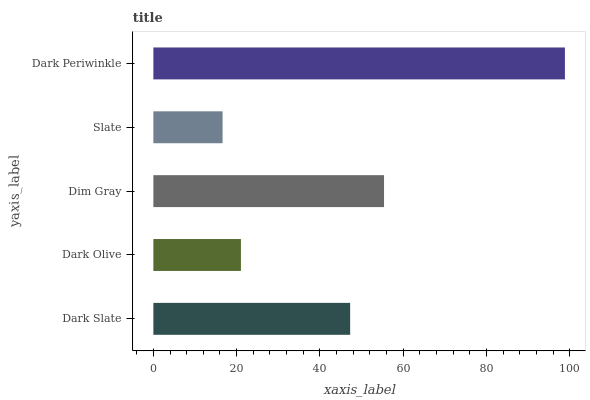Is Slate the minimum?
Answer yes or no. Yes. Is Dark Periwinkle the maximum?
Answer yes or no. Yes. Is Dark Olive the minimum?
Answer yes or no. No. Is Dark Olive the maximum?
Answer yes or no. No. Is Dark Slate greater than Dark Olive?
Answer yes or no. Yes. Is Dark Olive less than Dark Slate?
Answer yes or no. Yes. Is Dark Olive greater than Dark Slate?
Answer yes or no. No. Is Dark Slate less than Dark Olive?
Answer yes or no. No. Is Dark Slate the high median?
Answer yes or no. Yes. Is Dark Slate the low median?
Answer yes or no. Yes. Is Dark Olive the high median?
Answer yes or no. No. Is Dark Olive the low median?
Answer yes or no. No. 